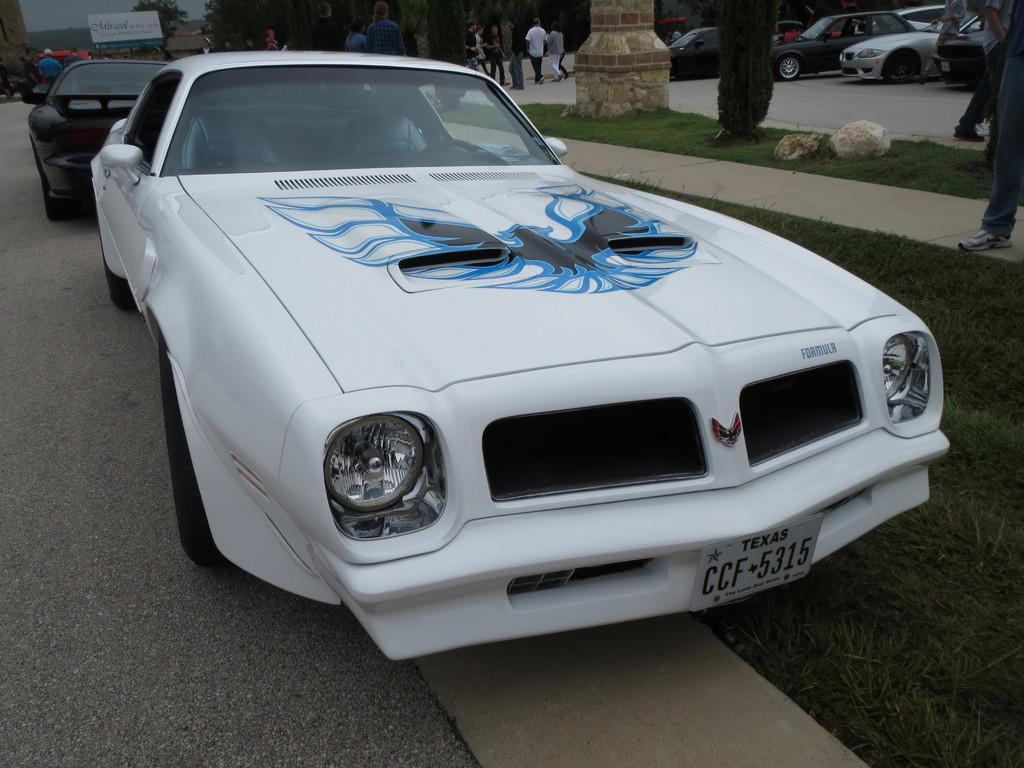What type of vehicles can be seen on the road in the image? There are cars on the road in the image. Can you identify any living beings in the image? Yes, there are people visible in the image. What type of natural elements are present in the image? Grass, plants, and stones are present in the image. What structure can be seen in the image? There is a pillar in the image. What can be seen in the background of the image? In the background, there are people, cars, trees, and a board. The sky is also visible in the background. Where is the throne located in the image? There is no throne present in the image. Is there an ongoing attack visible in the image? There is no attack present in the image. How many bikes can be seen in the image? There are no bikes visible in the image. 